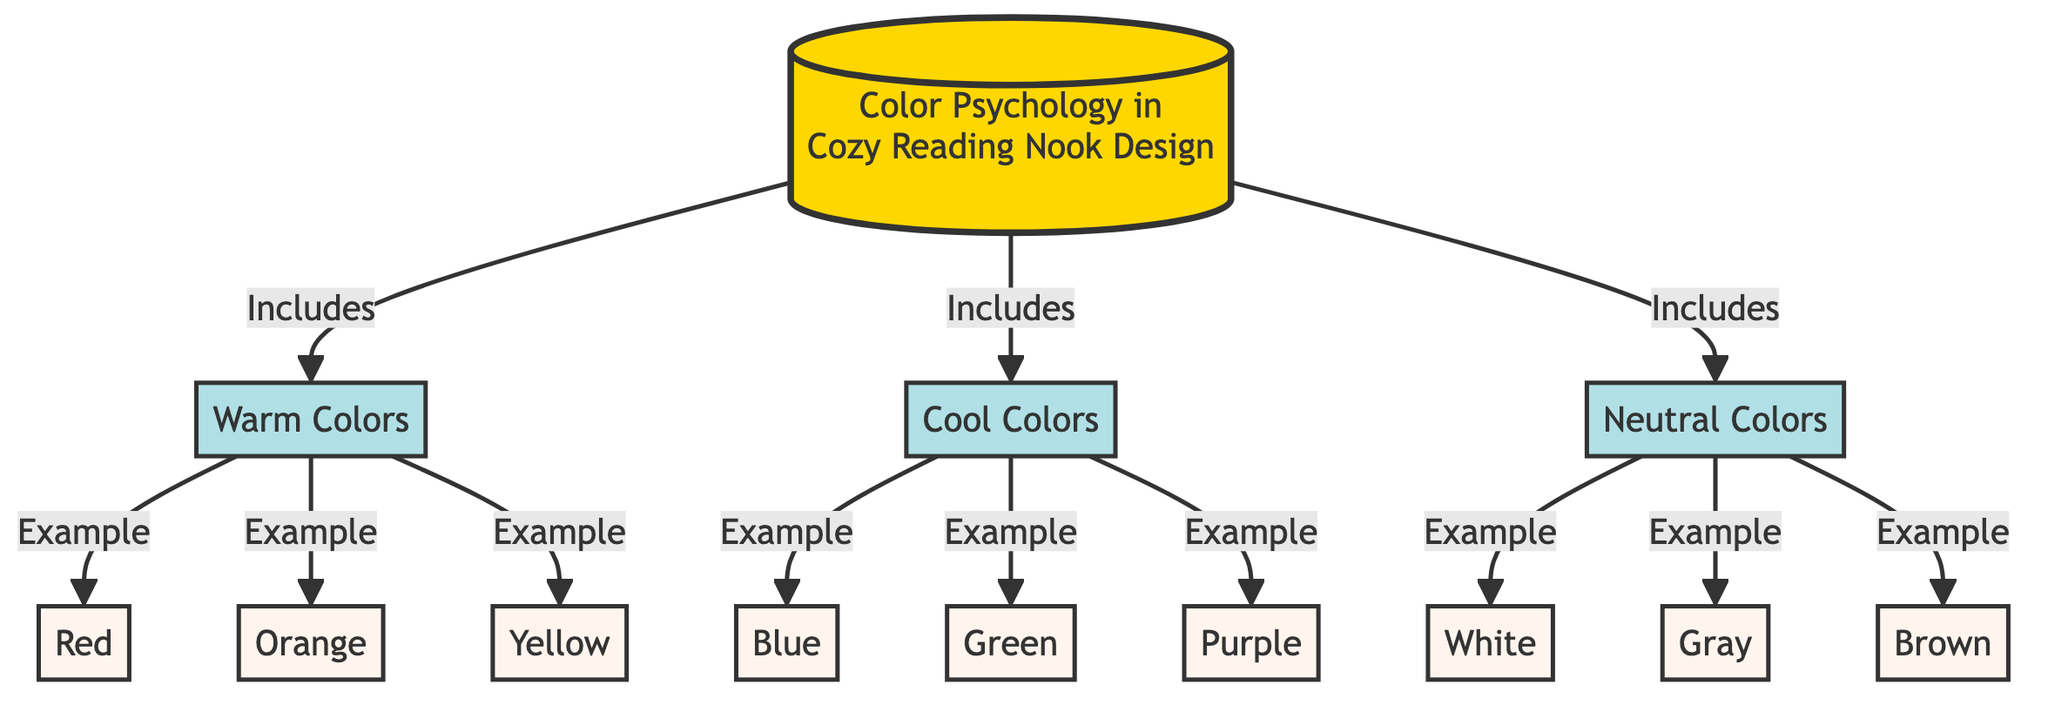What are the three main color categories in the diagram? The diagram lists three main color categories: Warm Colors, Cool Colors, and Neutral Colors.
Answer: Warm Colors, Cool Colors, Neutral Colors How many examples are provided under the Warm Colors category? Under the Warm Colors category, there are three examples listed: Red, Orange, and Yellow.
Answer: 3 What color is listed as an example of Cool Colors? One example under the Cool Colors category is Blue, which is specified alongside other colors like Green and Purple.
Answer: Blue Which color is associated with the Neutral Colors category? The Neutral Colors category includes White, Gray, and Brown, with White being one specific example mentioned.
Answer: White Is there any color in the diagram that belongs to both Warm Colors and Cool Colors? The diagram clearly categorizes colors without overlap, indicating that no color is classified under both Warm Colors and Cool Colors.
Answer: No 